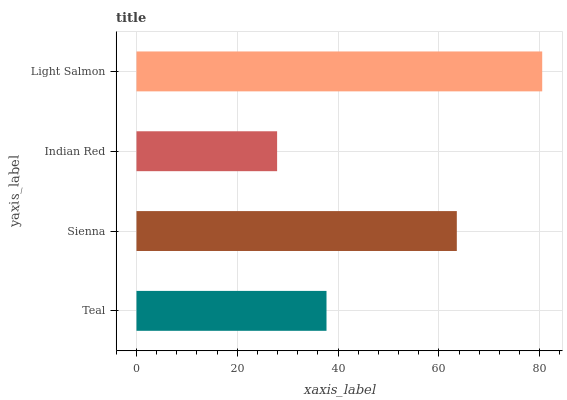Is Indian Red the minimum?
Answer yes or no. Yes. Is Light Salmon the maximum?
Answer yes or no. Yes. Is Sienna the minimum?
Answer yes or no. No. Is Sienna the maximum?
Answer yes or no. No. Is Sienna greater than Teal?
Answer yes or no. Yes. Is Teal less than Sienna?
Answer yes or no. Yes. Is Teal greater than Sienna?
Answer yes or no. No. Is Sienna less than Teal?
Answer yes or no. No. Is Sienna the high median?
Answer yes or no. Yes. Is Teal the low median?
Answer yes or no. Yes. Is Teal the high median?
Answer yes or no. No. Is Indian Red the low median?
Answer yes or no. No. 